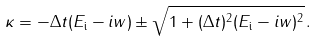Convert formula to latex. <formula><loc_0><loc_0><loc_500><loc_500>\kappa = - \Delta t ( E _ { \text {i} } - i w ) \pm \sqrt { 1 + ( \Delta t ) ^ { 2 } ( E _ { \text {i} } - i w ) ^ { 2 } } \, .</formula> 